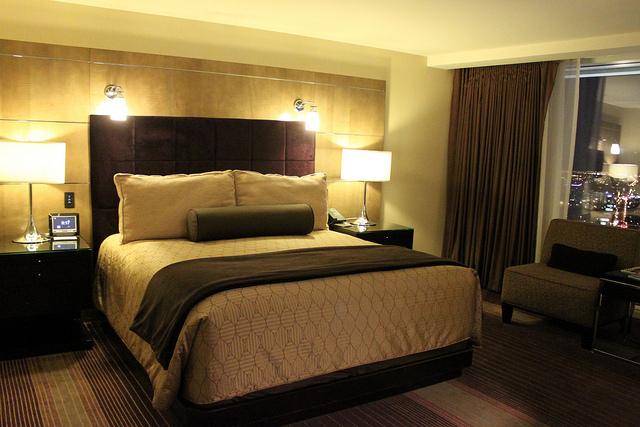Is there an alarm clock next to the bed?
Short answer required. Yes. How many pillows are on the bed?
Keep it brief. 3. What type of room is this?
Give a very brief answer. Bedroom. How many lamps are there?
Short answer required. 4. 